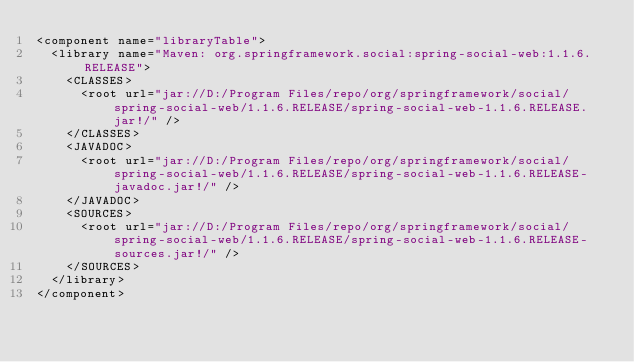<code> <loc_0><loc_0><loc_500><loc_500><_XML_><component name="libraryTable">
  <library name="Maven: org.springframework.social:spring-social-web:1.1.6.RELEASE">
    <CLASSES>
      <root url="jar://D:/Program Files/repo/org/springframework/social/spring-social-web/1.1.6.RELEASE/spring-social-web-1.1.6.RELEASE.jar!/" />
    </CLASSES>
    <JAVADOC>
      <root url="jar://D:/Program Files/repo/org/springframework/social/spring-social-web/1.1.6.RELEASE/spring-social-web-1.1.6.RELEASE-javadoc.jar!/" />
    </JAVADOC>
    <SOURCES>
      <root url="jar://D:/Program Files/repo/org/springframework/social/spring-social-web/1.1.6.RELEASE/spring-social-web-1.1.6.RELEASE-sources.jar!/" />
    </SOURCES>
  </library>
</component></code> 